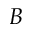<formula> <loc_0><loc_0><loc_500><loc_500>B</formula> 